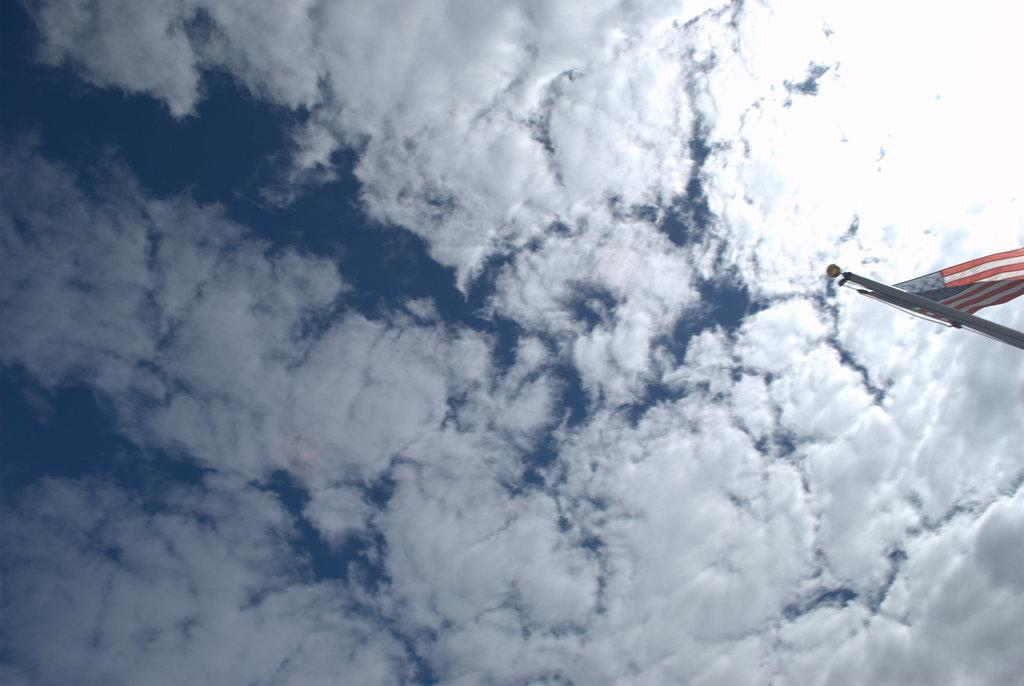What can be seen in the background of the image? The sky is visible in the image. What is the condition of the sky in the image? There are clouds in the sky. What object is present on a pole in the image? There is a flag on a pole in the image. How do the sisters play the instrument together in the image? There are no sisters or instruments present in the image; it only features a sky with clouds and a flag on a pole. 